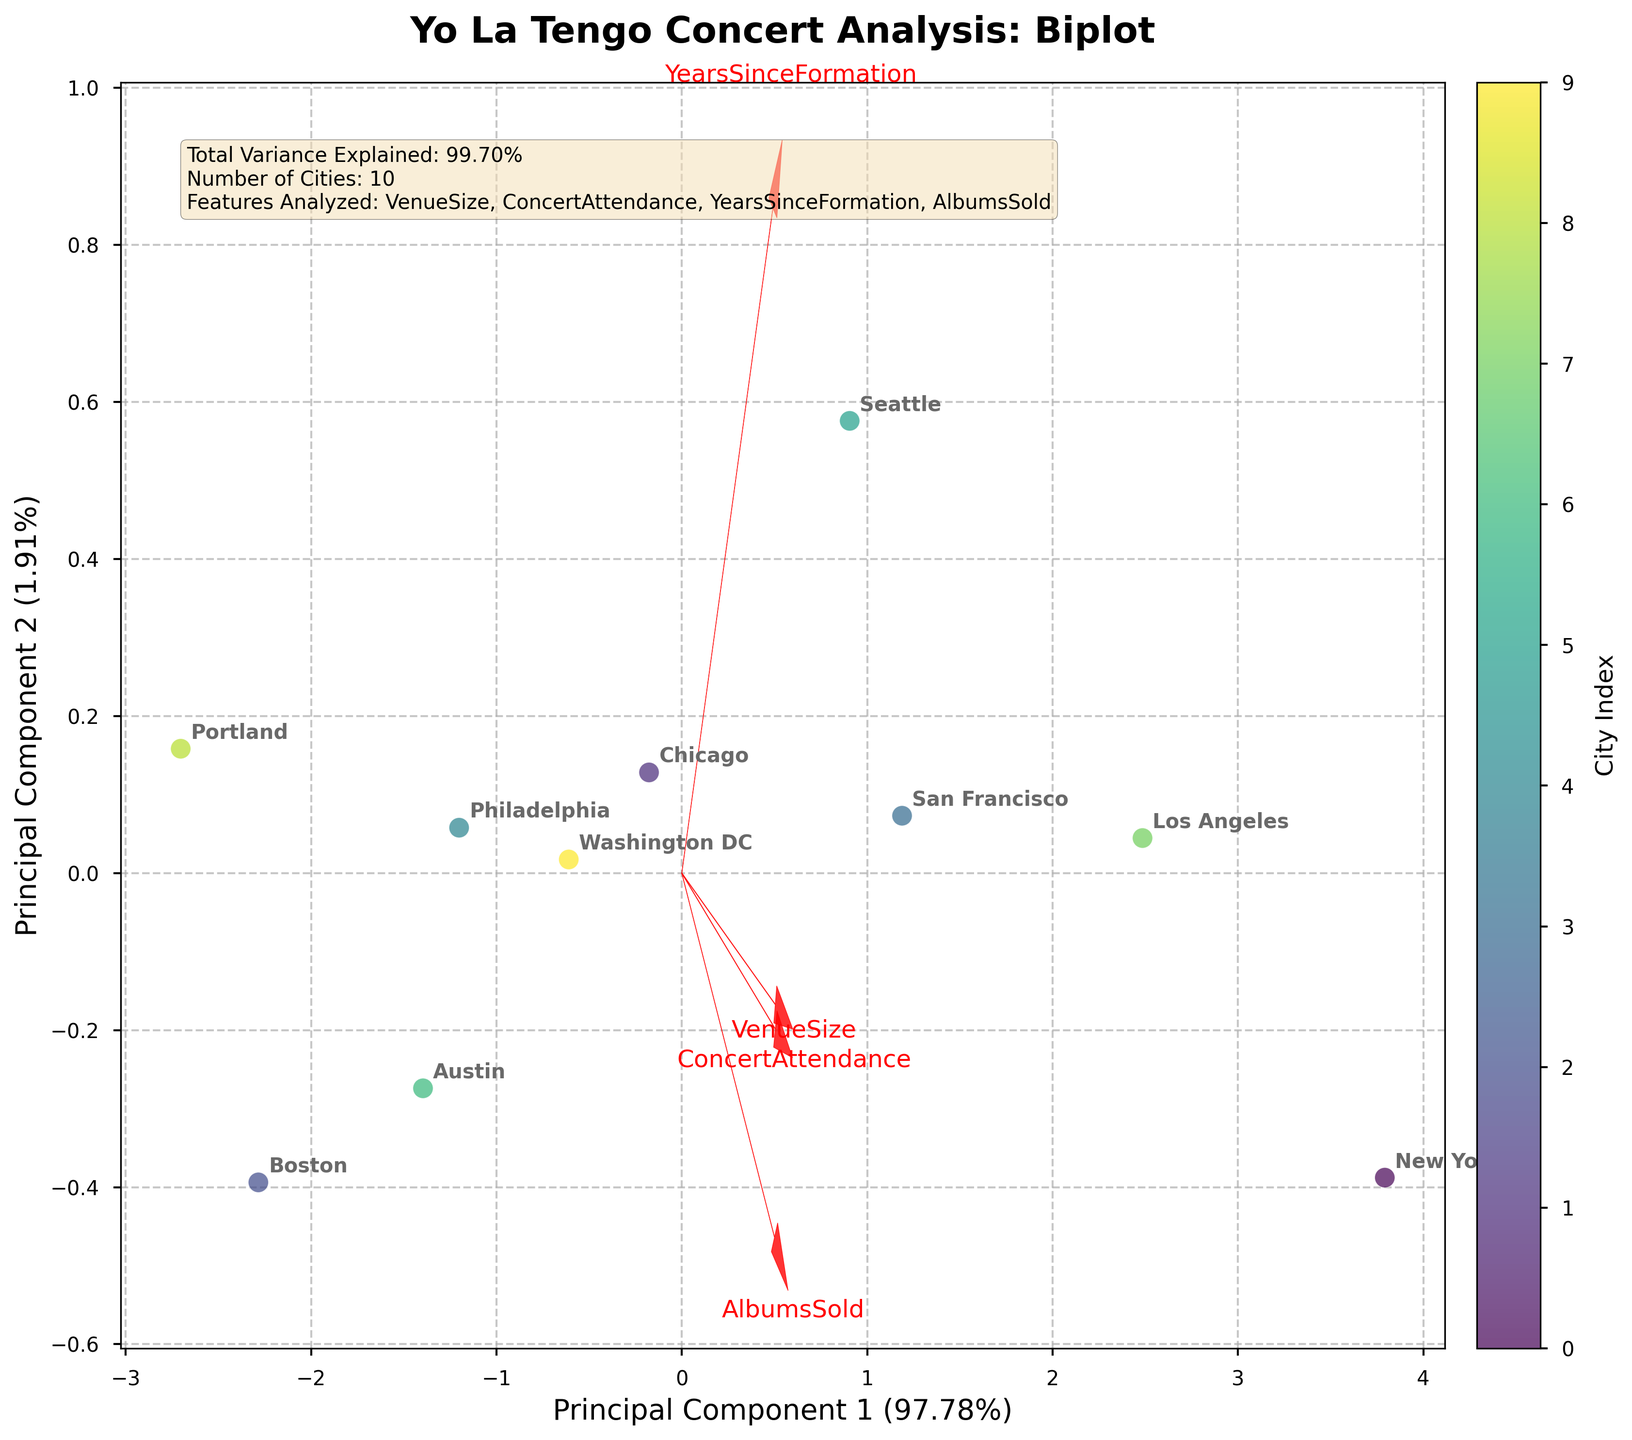How many cities are analyzed in the biplot? Look for the labels representing cities in the scatter plot; count the distinct city names annotated. Also, the text box indicates the count.
Answer: 10 What does the x-axis represent in the biplot? The label next to the x-axis indicates it represents "Principal Component 1" with an explained variance ratio of approximately 53%.
Answer: Principal Component 1 Which city is closest to the origin in the biplot? The city closest to the (0, 0) coordinates in the scatter plot is the one we're looking for.
Answer: Austin What is the relationship between "Concert Attendance" and the first principal component? Check the direction and length of the vector labeled "Concert Attendance". It's aligned positively with the first component, suggesting a strong positive relationship.
Answer: Positive relationship Which city has the highest concert attendance in the biplot? Identify the city whose "Concert Attendance" component is the largest. Cross-reference the vector of "Concert Attendance" correlation to distinguish further.
Answer: New York Between "VenueSize" and "AlbumsSold," which has a stronger influence on Principal Component 2? Compare the vectors of "VenueSize" and "AlbumsSold" relative to the second principal component. "AlbumsSold" will have a higher component if its vector is longer and more aligned with the y-axis.
Answer: AlbumsSold Which city is furthest away from others in the biplot? Look for the data point that is most distant from the cluster of other points; this represents the city we want.
Answer: New York How much total variance is explained by the two principal components combined? Refer to the text box in the plot which states the total variance explained.
Answer: 86% Is there a high correlation between "Venue Size" and "Concert Attendance"? Check if both vectors for "VenueSize" and "ConcertAttendance" point in similar directions and have similar magnitudes. This indicates a high correlation.
Answer: Yes Which cities seem to have a similar profile based on the biplot? Cities that are close to each other in the biplot should have similar profiles across the features analyzed.
Answer: Chicago and Philadelphia 